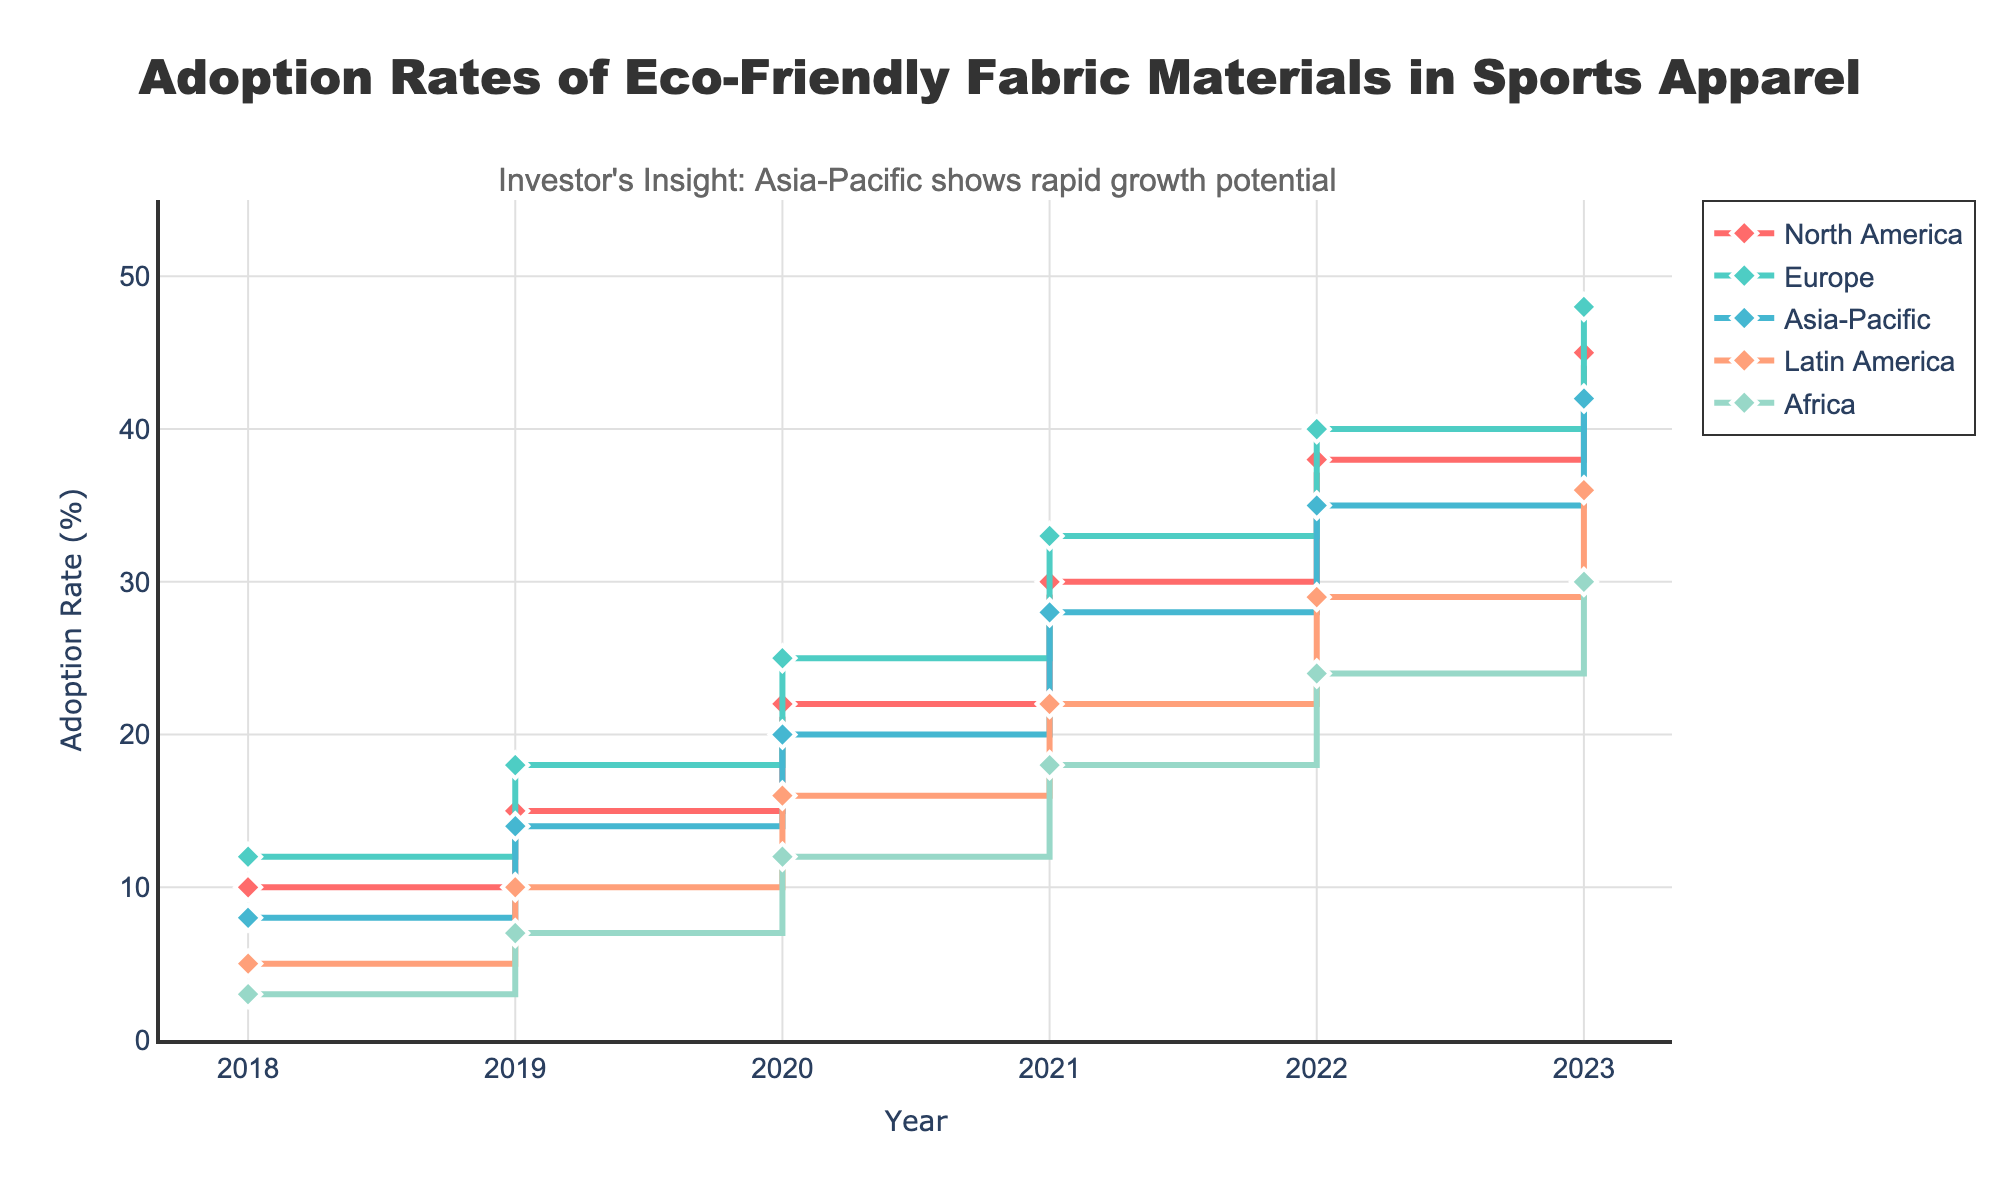What's the title of the figure? The title is displayed prominently at the top of the figure.
Answer: Adoption Rates of Eco-Friendly Fabric Materials in Sports Apparel What is the x-axis title? The x-axis title is located along the horizontal axis of the plot.
Answer: Year Which region had the highest adoption rate in 2023? Look at the endpoints of the lines for 2023 and compare the values.
Answer: Europe How does the adoption rate in North America in 2019 compare to Africa in 2019? Locate the points for North America and Africa in 2019 and compare their y-axis values. North America is at 15%, and Africa is at 7%, so North America has a higher adoption rate.
Answer: North America is higher Which two regions show the smallest gap in adoption rate in 2021? Find the adoption rates for all regions in 2021 and determine the difference between each pair. The smallest differences are between Latin America and Africa (both have a difference of 4%).
Answer: Latin America and Africa Calculate the average adoption rate for Asia-Pacific from 2018 to 2023. Sum the adoption rates for Asia-Pacific for the years 2018 (8%), 2019 (14%), 2020 (20%), 2021 (28%), 2022 (35%), and 2023 (42%) and divide by 6. \( \frac{8 + 14 + 20 + 28 + 35 + 42}{6} = 24.5 \)
Answer: 24.5% Which region has shown the most consistent growth in adoption rates over the years? Examine the shape and consistency of the lines for each region. Find the line with the smallest year-to-year variation in slope. All regions have steady growth, but Europe and North America are particularly consistent.
Answer: Europe What is the difference in adoption rate between Europe and Asia-Pacific in 2022? Locate the 2022 points for Europe (40%) and Asia-Pacific (35%) and subtract Asia-Pacific's adoption rate from Europe's. \( 40 - 35 = 5 \)
Answer: 5% Which region had the fastest growth rate in adoption rate between 2018 and 2023? Compare the slopes of the lines from 2018 to 2023. Faster growth is indicated by a steeper slope. Both Europe and North America show rapid growth, but Asia-Pacific shows notable acceleration as well.
Answer: Europe According to the annotation, which region shows rapid growth potential? Read the provided annotation text in the figure.
Answer: Asia-Pacific 